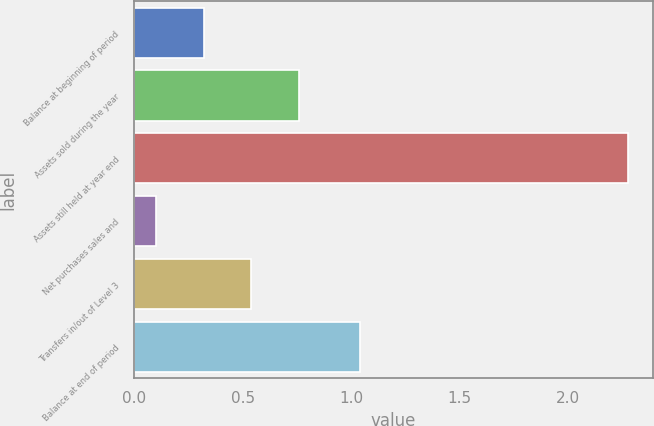<chart> <loc_0><loc_0><loc_500><loc_500><bar_chart><fcel>Balance at beginning of period<fcel>Assets sold during the year<fcel>Assets still held at year end<fcel>Net purchases sales and<fcel>Transfers in/out of Level 3<fcel>Balance at end of period<nl><fcel>0.32<fcel>0.76<fcel>2.28<fcel>0.1<fcel>0.54<fcel>1.04<nl></chart> 